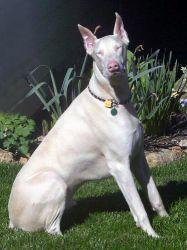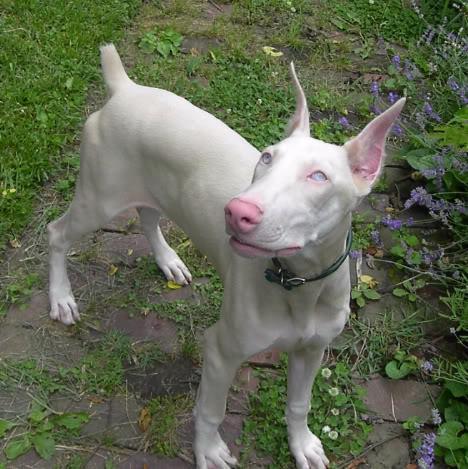The first image is the image on the left, the second image is the image on the right. For the images shown, is this caption "Three or more dogs are visible." true? Answer yes or no. No. The first image is the image on the left, the second image is the image on the right. For the images shown, is this caption "At least one dog is laying down." true? Answer yes or no. No. 